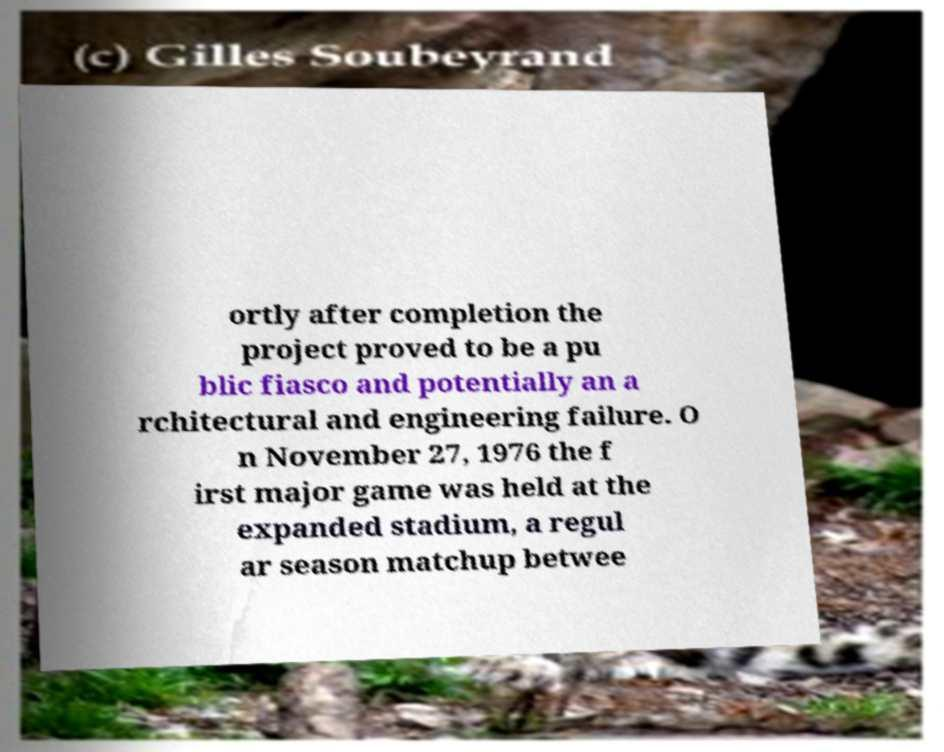Can you accurately transcribe the text from the provided image for me? ortly after completion the project proved to be a pu blic fiasco and potentially an a rchitectural and engineering failure. O n November 27, 1976 the f irst major game was held at the expanded stadium, a regul ar season matchup betwee 